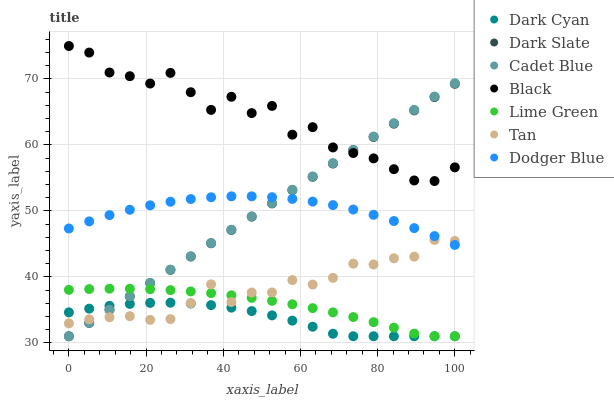Does Dark Cyan have the minimum area under the curve?
Answer yes or no. Yes. Does Black have the maximum area under the curve?
Answer yes or no. Yes. Does Dark Slate have the minimum area under the curve?
Answer yes or no. No. Does Dark Slate have the maximum area under the curve?
Answer yes or no. No. Is Cadet Blue the smoothest?
Answer yes or no. Yes. Is Black the roughest?
Answer yes or no. Yes. Is Dark Slate the smoothest?
Answer yes or no. No. Is Dark Slate the roughest?
Answer yes or no. No. Does Cadet Blue have the lowest value?
Answer yes or no. Yes. Does Black have the lowest value?
Answer yes or no. No. Does Black have the highest value?
Answer yes or no. Yes. Does Dark Slate have the highest value?
Answer yes or no. No. Is Dark Cyan less than Black?
Answer yes or no. Yes. Is Black greater than Dodger Blue?
Answer yes or no. Yes. Does Dark Slate intersect Cadet Blue?
Answer yes or no. Yes. Is Dark Slate less than Cadet Blue?
Answer yes or no. No. Is Dark Slate greater than Cadet Blue?
Answer yes or no. No. Does Dark Cyan intersect Black?
Answer yes or no. No. 